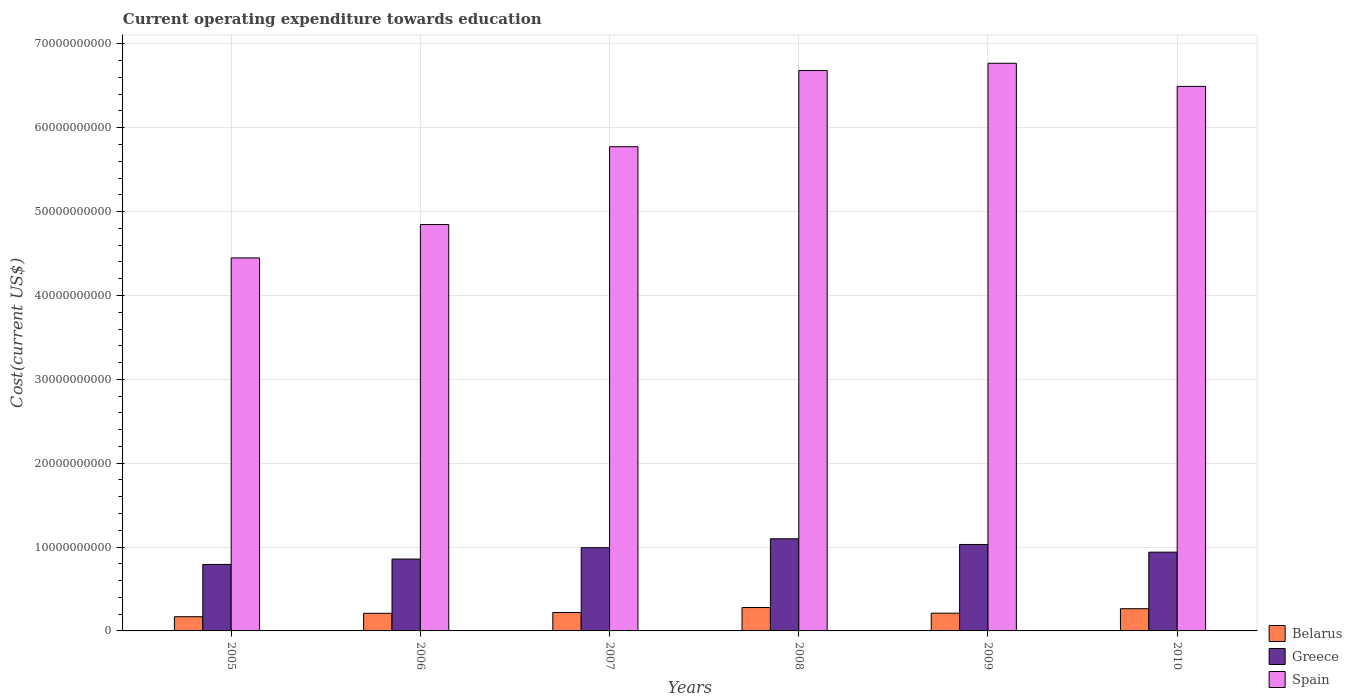How many different coloured bars are there?
Offer a terse response. 3. How many groups of bars are there?
Ensure brevity in your answer.  6. How many bars are there on the 5th tick from the right?
Make the answer very short. 3. What is the label of the 1st group of bars from the left?
Your answer should be compact. 2005. What is the expenditure towards education in Greece in 2005?
Your answer should be very brief. 7.93e+09. Across all years, what is the maximum expenditure towards education in Spain?
Offer a terse response. 6.77e+1. Across all years, what is the minimum expenditure towards education in Greece?
Your answer should be very brief. 7.93e+09. In which year was the expenditure towards education in Spain minimum?
Provide a short and direct response. 2005. What is the total expenditure towards education in Greece in the graph?
Your answer should be compact. 5.71e+1. What is the difference between the expenditure towards education in Belarus in 2005 and that in 2006?
Offer a terse response. -4.05e+08. What is the difference between the expenditure towards education in Greece in 2005 and the expenditure towards education in Belarus in 2006?
Offer a very short reply. 5.83e+09. What is the average expenditure towards education in Spain per year?
Your answer should be compact. 5.84e+1. In the year 2005, what is the difference between the expenditure towards education in Spain and expenditure towards education in Belarus?
Keep it short and to the point. 4.28e+1. What is the ratio of the expenditure towards education in Spain in 2005 to that in 2010?
Ensure brevity in your answer.  0.69. Is the difference between the expenditure towards education in Spain in 2008 and 2010 greater than the difference between the expenditure towards education in Belarus in 2008 and 2010?
Provide a short and direct response. Yes. What is the difference between the highest and the second highest expenditure towards education in Spain?
Ensure brevity in your answer.  8.66e+08. What is the difference between the highest and the lowest expenditure towards education in Greece?
Keep it short and to the point. 3.06e+09. In how many years, is the expenditure towards education in Spain greater than the average expenditure towards education in Spain taken over all years?
Provide a succinct answer. 3. Is the sum of the expenditure towards education in Greece in 2007 and 2010 greater than the maximum expenditure towards education in Belarus across all years?
Offer a terse response. Yes. What does the 2nd bar from the left in 2006 represents?
Provide a succinct answer. Greece. What does the 3rd bar from the right in 2005 represents?
Keep it short and to the point. Belarus. Is it the case that in every year, the sum of the expenditure towards education in Belarus and expenditure towards education in Spain is greater than the expenditure towards education in Greece?
Provide a short and direct response. Yes. Are all the bars in the graph horizontal?
Offer a terse response. No. Where does the legend appear in the graph?
Your answer should be compact. Bottom right. What is the title of the graph?
Ensure brevity in your answer.  Current operating expenditure towards education. What is the label or title of the X-axis?
Keep it short and to the point. Years. What is the label or title of the Y-axis?
Offer a terse response. Cost(current US$). What is the Cost(current US$) in Belarus in 2005?
Provide a succinct answer. 1.69e+09. What is the Cost(current US$) in Greece in 2005?
Keep it short and to the point. 7.93e+09. What is the Cost(current US$) in Spain in 2005?
Ensure brevity in your answer.  4.45e+1. What is the Cost(current US$) in Belarus in 2006?
Keep it short and to the point. 2.10e+09. What is the Cost(current US$) in Greece in 2006?
Your answer should be very brief. 8.57e+09. What is the Cost(current US$) in Spain in 2006?
Your response must be concise. 4.85e+1. What is the Cost(current US$) of Belarus in 2007?
Provide a short and direct response. 2.20e+09. What is the Cost(current US$) of Greece in 2007?
Your response must be concise. 9.92e+09. What is the Cost(current US$) in Spain in 2007?
Your response must be concise. 5.77e+1. What is the Cost(current US$) in Belarus in 2008?
Your answer should be compact. 2.79e+09. What is the Cost(current US$) in Greece in 2008?
Offer a terse response. 1.10e+1. What is the Cost(current US$) of Spain in 2008?
Give a very brief answer. 6.68e+1. What is the Cost(current US$) of Belarus in 2009?
Your response must be concise. 2.12e+09. What is the Cost(current US$) in Greece in 2009?
Keep it short and to the point. 1.03e+1. What is the Cost(current US$) of Spain in 2009?
Your answer should be very brief. 6.77e+1. What is the Cost(current US$) of Belarus in 2010?
Give a very brief answer. 2.65e+09. What is the Cost(current US$) of Greece in 2010?
Ensure brevity in your answer.  9.39e+09. What is the Cost(current US$) in Spain in 2010?
Make the answer very short. 6.49e+1. Across all years, what is the maximum Cost(current US$) of Belarus?
Offer a very short reply. 2.79e+09. Across all years, what is the maximum Cost(current US$) in Greece?
Keep it short and to the point. 1.10e+1. Across all years, what is the maximum Cost(current US$) in Spain?
Your response must be concise. 6.77e+1. Across all years, what is the minimum Cost(current US$) in Belarus?
Offer a terse response. 1.69e+09. Across all years, what is the minimum Cost(current US$) in Greece?
Ensure brevity in your answer.  7.93e+09. Across all years, what is the minimum Cost(current US$) in Spain?
Provide a short and direct response. 4.45e+1. What is the total Cost(current US$) of Belarus in the graph?
Provide a short and direct response. 1.35e+1. What is the total Cost(current US$) of Greece in the graph?
Give a very brief answer. 5.71e+1. What is the total Cost(current US$) in Spain in the graph?
Your response must be concise. 3.50e+11. What is the difference between the Cost(current US$) in Belarus in 2005 and that in 2006?
Offer a very short reply. -4.05e+08. What is the difference between the Cost(current US$) in Greece in 2005 and that in 2006?
Ensure brevity in your answer.  -6.41e+08. What is the difference between the Cost(current US$) of Spain in 2005 and that in 2006?
Offer a terse response. -3.98e+09. What is the difference between the Cost(current US$) of Belarus in 2005 and that in 2007?
Your answer should be very brief. -5.04e+08. What is the difference between the Cost(current US$) in Greece in 2005 and that in 2007?
Provide a succinct answer. -2.00e+09. What is the difference between the Cost(current US$) of Spain in 2005 and that in 2007?
Give a very brief answer. -1.33e+1. What is the difference between the Cost(current US$) in Belarus in 2005 and that in 2008?
Offer a very short reply. -1.09e+09. What is the difference between the Cost(current US$) in Greece in 2005 and that in 2008?
Offer a very short reply. -3.06e+09. What is the difference between the Cost(current US$) of Spain in 2005 and that in 2008?
Provide a short and direct response. -2.23e+1. What is the difference between the Cost(current US$) of Belarus in 2005 and that in 2009?
Your answer should be compact. -4.21e+08. What is the difference between the Cost(current US$) of Greece in 2005 and that in 2009?
Offer a very short reply. -2.38e+09. What is the difference between the Cost(current US$) in Spain in 2005 and that in 2009?
Offer a terse response. -2.32e+1. What is the difference between the Cost(current US$) in Belarus in 2005 and that in 2010?
Keep it short and to the point. -9.54e+08. What is the difference between the Cost(current US$) of Greece in 2005 and that in 2010?
Your response must be concise. -1.46e+09. What is the difference between the Cost(current US$) in Spain in 2005 and that in 2010?
Your answer should be very brief. -2.05e+1. What is the difference between the Cost(current US$) in Belarus in 2006 and that in 2007?
Your response must be concise. -9.81e+07. What is the difference between the Cost(current US$) of Greece in 2006 and that in 2007?
Offer a very short reply. -1.35e+09. What is the difference between the Cost(current US$) of Spain in 2006 and that in 2007?
Your answer should be compact. -9.28e+09. What is the difference between the Cost(current US$) of Belarus in 2006 and that in 2008?
Make the answer very short. -6.88e+08. What is the difference between the Cost(current US$) in Greece in 2006 and that in 2008?
Provide a succinct answer. -2.42e+09. What is the difference between the Cost(current US$) of Spain in 2006 and that in 2008?
Provide a succinct answer. -1.84e+1. What is the difference between the Cost(current US$) in Belarus in 2006 and that in 2009?
Provide a succinct answer. -1.59e+07. What is the difference between the Cost(current US$) of Greece in 2006 and that in 2009?
Give a very brief answer. -1.74e+09. What is the difference between the Cost(current US$) of Spain in 2006 and that in 2009?
Provide a succinct answer. -1.92e+1. What is the difference between the Cost(current US$) in Belarus in 2006 and that in 2010?
Provide a succinct answer. -5.49e+08. What is the difference between the Cost(current US$) of Greece in 2006 and that in 2010?
Your answer should be compact. -8.21e+08. What is the difference between the Cost(current US$) in Spain in 2006 and that in 2010?
Provide a succinct answer. -1.65e+1. What is the difference between the Cost(current US$) of Belarus in 2007 and that in 2008?
Provide a succinct answer. -5.90e+08. What is the difference between the Cost(current US$) of Greece in 2007 and that in 2008?
Keep it short and to the point. -1.06e+09. What is the difference between the Cost(current US$) in Spain in 2007 and that in 2008?
Provide a short and direct response. -9.08e+09. What is the difference between the Cost(current US$) in Belarus in 2007 and that in 2009?
Your answer should be very brief. 8.22e+07. What is the difference between the Cost(current US$) in Greece in 2007 and that in 2009?
Your answer should be compact. -3.84e+08. What is the difference between the Cost(current US$) in Spain in 2007 and that in 2009?
Your response must be concise. -9.95e+09. What is the difference between the Cost(current US$) of Belarus in 2007 and that in 2010?
Make the answer very short. -4.50e+08. What is the difference between the Cost(current US$) of Greece in 2007 and that in 2010?
Provide a short and direct response. 5.33e+08. What is the difference between the Cost(current US$) in Spain in 2007 and that in 2010?
Your response must be concise. -7.19e+09. What is the difference between the Cost(current US$) in Belarus in 2008 and that in 2009?
Offer a very short reply. 6.72e+08. What is the difference between the Cost(current US$) in Greece in 2008 and that in 2009?
Offer a terse response. 6.80e+08. What is the difference between the Cost(current US$) of Spain in 2008 and that in 2009?
Provide a short and direct response. -8.66e+08. What is the difference between the Cost(current US$) of Belarus in 2008 and that in 2010?
Your answer should be compact. 1.39e+08. What is the difference between the Cost(current US$) of Greece in 2008 and that in 2010?
Make the answer very short. 1.60e+09. What is the difference between the Cost(current US$) in Spain in 2008 and that in 2010?
Give a very brief answer. 1.89e+09. What is the difference between the Cost(current US$) of Belarus in 2009 and that in 2010?
Give a very brief answer. -5.33e+08. What is the difference between the Cost(current US$) of Greece in 2009 and that in 2010?
Give a very brief answer. 9.18e+08. What is the difference between the Cost(current US$) in Spain in 2009 and that in 2010?
Offer a terse response. 2.76e+09. What is the difference between the Cost(current US$) of Belarus in 2005 and the Cost(current US$) of Greece in 2006?
Offer a very short reply. -6.88e+09. What is the difference between the Cost(current US$) in Belarus in 2005 and the Cost(current US$) in Spain in 2006?
Give a very brief answer. -4.68e+1. What is the difference between the Cost(current US$) in Greece in 2005 and the Cost(current US$) in Spain in 2006?
Your response must be concise. -4.05e+1. What is the difference between the Cost(current US$) of Belarus in 2005 and the Cost(current US$) of Greece in 2007?
Provide a short and direct response. -8.23e+09. What is the difference between the Cost(current US$) of Belarus in 2005 and the Cost(current US$) of Spain in 2007?
Give a very brief answer. -5.60e+1. What is the difference between the Cost(current US$) in Greece in 2005 and the Cost(current US$) in Spain in 2007?
Provide a short and direct response. -4.98e+1. What is the difference between the Cost(current US$) of Belarus in 2005 and the Cost(current US$) of Greece in 2008?
Give a very brief answer. -9.29e+09. What is the difference between the Cost(current US$) of Belarus in 2005 and the Cost(current US$) of Spain in 2008?
Your response must be concise. -6.51e+1. What is the difference between the Cost(current US$) of Greece in 2005 and the Cost(current US$) of Spain in 2008?
Your response must be concise. -5.89e+1. What is the difference between the Cost(current US$) of Belarus in 2005 and the Cost(current US$) of Greece in 2009?
Provide a succinct answer. -8.61e+09. What is the difference between the Cost(current US$) of Belarus in 2005 and the Cost(current US$) of Spain in 2009?
Your answer should be very brief. -6.60e+1. What is the difference between the Cost(current US$) in Greece in 2005 and the Cost(current US$) in Spain in 2009?
Make the answer very short. -5.98e+1. What is the difference between the Cost(current US$) in Belarus in 2005 and the Cost(current US$) in Greece in 2010?
Your answer should be very brief. -7.70e+09. What is the difference between the Cost(current US$) of Belarus in 2005 and the Cost(current US$) of Spain in 2010?
Offer a terse response. -6.32e+1. What is the difference between the Cost(current US$) in Greece in 2005 and the Cost(current US$) in Spain in 2010?
Make the answer very short. -5.70e+1. What is the difference between the Cost(current US$) in Belarus in 2006 and the Cost(current US$) in Greece in 2007?
Offer a very short reply. -7.82e+09. What is the difference between the Cost(current US$) in Belarus in 2006 and the Cost(current US$) in Spain in 2007?
Your answer should be very brief. -5.56e+1. What is the difference between the Cost(current US$) of Greece in 2006 and the Cost(current US$) of Spain in 2007?
Offer a very short reply. -4.92e+1. What is the difference between the Cost(current US$) in Belarus in 2006 and the Cost(current US$) in Greece in 2008?
Make the answer very short. -8.89e+09. What is the difference between the Cost(current US$) in Belarus in 2006 and the Cost(current US$) in Spain in 2008?
Make the answer very short. -6.47e+1. What is the difference between the Cost(current US$) in Greece in 2006 and the Cost(current US$) in Spain in 2008?
Provide a succinct answer. -5.83e+1. What is the difference between the Cost(current US$) of Belarus in 2006 and the Cost(current US$) of Greece in 2009?
Your response must be concise. -8.21e+09. What is the difference between the Cost(current US$) in Belarus in 2006 and the Cost(current US$) in Spain in 2009?
Your answer should be compact. -6.56e+1. What is the difference between the Cost(current US$) in Greece in 2006 and the Cost(current US$) in Spain in 2009?
Make the answer very short. -5.91e+1. What is the difference between the Cost(current US$) of Belarus in 2006 and the Cost(current US$) of Greece in 2010?
Ensure brevity in your answer.  -7.29e+09. What is the difference between the Cost(current US$) in Belarus in 2006 and the Cost(current US$) in Spain in 2010?
Keep it short and to the point. -6.28e+1. What is the difference between the Cost(current US$) in Greece in 2006 and the Cost(current US$) in Spain in 2010?
Give a very brief answer. -5.64e+1. What is the difference between the Cost(current US$) in Belarus in 2007 and the Cost(current US$) in Greece in 2008?
Your response must be concise. -8.79e+09. What is the difference between the Cost(current US$) of Belarus in 2007 and the Cost(current US$) of Spain in 2008?
Provide a short and direct response. -6.46e+1. What is the difference between the Cost(current US$) in Greece in 2007 and the Cost(current US$) in Spain in 2008?
Keep it short and to the point. -5.69e+1. What is the difference between the Cost(current US$) of Belarus in 2007 and the Cost(current US$) of Greece in 2009?
Make the answer very short. -8.11e+09. What is the difference between the Cost(current US$) in Belarus in 2007 and the Cost(current US$) in Spain in 2009?
Give a very brief answer. -6.55e+1. What is the difference between the Cost(current US$) of Greece in 2007 and the Cost(current US$) of Spain in 2009?
Provide a succinct answer. -5.78e+1. What is the difference between the Cost(current US$) in Belarus in 2007 and the Cost(current US$) in Greece in 2010?
Offer a very short reply. -7.19e+09. What is the difference between the Cost(current US$) of Belarus in 2007 and the Cost(current US$) of Spain in 2010?
Provide a short and direct response. -6.27e+1. What is the difference between the Cost(current US$) in Greece in 2007 and the Cost(current US$) in Spain in 2010?
Your response must be concise. -5.50e+1. What is the difference between the Cost(current US$) of Belarus in 2008 and the Cost(current US$) of Greece in 2009?
Provide a short and direct response. -7.52e+09. What is the difference between the Cost(current US$) in Belarus in 2008 and the Cost(current US$) in Spain in 2009?
Give a very brief answer. -6.49e+1. What is the difference between the Cost(current US$) of Greece in 2008 and the Cost(current US$) of Spain in 2009?
Make the answer very short. -5.67e+1. What is the difference between the Cost(current US$) of Belarus in 2008 and the Cost(current US$) of Greece in 2010?
Your answer should be compact. -6.60e+09. What is the difference between the Cost(current US$) in Belarus in 2008 and the Cost(current US$) in Spain in 2010?
Keep it short and to the point. -6.21e+1. What is the difference between the Cost(current US$) in Greece in 2008 and the Cost(current US$) in Spain in 2010?
Ensure brevity in your answer.  -5.39e+1. What is the difference between the Cost(current US$) in Belarus in 2009 and the Cost(current US$) in Greece in 2010?
Offer a terse response. -7.27e+09. What is the difference between the Cost(current US$) in Belarus in 2009 and the Cost(current US$) in Spain in 2010?
Give a very brief answer. -6.28e+1. What is the difference between the Cost(current US$) in Greece in 2009 and the Cost(current US$) in Spain in 2010?
Ensure brevity in your answer.  -5.46e+1. What is the average Cost(current US$) of Belarus per year?
Give a very brief answer. 2.26e+09. What is the average Cost(current US$) in Greece per year?
Your answer should be very brief. 9.52e+09. What is the average Cost(current US$) of Spain per year?
Provide a short and direct response. 5.84e+1. In the year 2005, what is the difference between the Cost(current US$) in Belarus and Cost(current US$) in Greece?
Make the answer very short. -6.23e+09. In the year 2005, what is the difference between the Cost(current US$) of Belarus and Cost(current US$) of Spain?
Offer a very short reply. -4.28e+1. In the year 2005, what is the difference between the Cost(current US$) of Greece and Cost(current US$) of Spain?
Provide a short and direct response. -3.66e+1. In the year 2006, what is the difference between the Cost(current US$) of Belarus and Cost(current US$) of Greece?
Your answer should be compact. -6.47e+09. In the year 2006, what is the difference between the Cost(current US$) in Belarus and Cost(current US$) in Spain?
Your answer should be very brief. -4.64e+1. In the year 2006, what is the difference between the Cost(current US$) of Greece and Cost(current US$) of Spain?
Provide a short and direct response. -3.99e+1. In the year 2007, what is the difference between the Cost(current US$) in Belarus and Cost(current US$) in Greece?
Ensure brevity in your answer.  -7.73e+09. In the year 2007, what is the difference between the Cost(current US$) of Belarus and Cost(current US$) of Spain?
Give a very brief answer. -5.55e+1. In the year 2007, what is the difference between the Cost(current US$) of Greece and Cost(current US$) of Spain?
Make the answer very short. -4.78e+1. In the year 2008, what is the difference between the Cost(current US$) in Belarus and Cost(current US$) in Greece?
Your response must be concise. -8.20e+09. In the year 2008, what is the difference between the Cost(current US$) in Belarus and Cost(current US$) in Spain?
Your answer should be very brief. -6.40e+1. In the year 2008, what is the difference between the Cost(current US$) of Greece and Cost(current US$) of Spain?
Your answer should be very brief. -5.58e+1. In the year 2009, what is the difference between the Cost(current US$) in Belarus and Cost(current US$) in Greece?
Keep it short and to the point. -8.19e+09. In the year 2009, what is the difference between the Cost(current US$) of Belarus and Cost(current US$) of Spain?
Make the answer very short. -6.56e+1. In the year 2009, what is the difference between the Cost(current US$) of Greece and Cost(current US$) of Spain?
Ensure brevity in your answer.  -5.74e+1. In the year 2010, what is the difference between the Cost(current US$) in Belarus and Cost(current US$) in Greece?
Your response must be concise. -6.74e+09. In the year 2010, what is the difference between the Cost(current US$) in Belarus and Cost(current US$) in Spain?
Your answer should be very brief. -6.23e+1. In the year 2010, what is the difference between the Cost(current US$) of Greece and Cost(current US$) of Spain?
Ensure brevity in your answer.  -5.55e+1. What is the ratio of the Cost(current US$) of Belarus in 2005 to that in 2006?
Make the answer very short. 0.81. What is the ratio of the Cost(current US$) of Greece in 2005 to that in 2006?
Keep it short and to the point. 0.93. What is the ratio of the Cost(current US$) of Spain in 2005 to that in 2006?
Your response must be concise. 0.92. What is the ratio of the Cost(current US$) of Belarus in 2005 to that in 2007?
Give a very brief answer. 0.77. What is the ratio of the Cost(current US$) in Greece in 2005 to that in 2007?
Your answer should be very brief. 0.8. What is the ratio of the Cost(current US$) in Spain in 2005 to that in 2007?
Your answer should be compact. 0.77. What is the ratio of the Cost(current US$) in Belarus in 2005 to that in 2008?
Offer a terse response. 0.61. What is the ratio of the Cost(current US$) in Greece in 2005 to that in 2008?
Give a very brief answer. 0.72. What is the ratio of the Cost(current US$) of Spain in 2005 to that in 2008?
Offer a terse response. 0.67. What is the ratio of the Cost(current US$) of Belarus in 2005 to that in 2009?
Your response must be concise. 0.8. What is the ratio of the Cost(current US$) of Greece in 2005 to that in 2009?
Offer a terse response. 0.77. What is the ratio of the Cost(current US$) of Spain in 2005 to that in 2009?
Your response must be concise. 0.66. What is the ratio of the Cost(current US$) in Belarus in 2005 to that in 2010?
Offer a very short reply. 0.64. What is the ratio of the Cost(current US$) of Greece in 2005 to that in 2010?
Ensure brevity in your answer.  0.84. What is the ratio of the Cost(current US$) in Spain in 2005 to that in 2010?
Give a very brief answer. 0.69. What is the ratio of the Cost(current US$) in Belarus in 2006 to that in 2007?
Make the answer very short. 0.96. What is the ratio of the Cost(current US$) in Greece in 2006 to that in 2007?
Provide a short and direct response. 0.86. What is the ratio of the Cost(current US$) in Spain in 2006 to that in 2007?
Ensure brevity in your answer.  0.84. What is the ratio of the Cost(current US$) of Belarus in 2006 to that in 2008?
Offer a terse response. 0.75. What is the ratio of the Cost(current US$) of Greece in 2006 to that in 2008?
Keep it short and to the point. 0.78. What is the ratio of the Cost(current US$) of Spain in 2006 to that in 2008?
Your answer should be very brief. 0.73. What is the ratio of the Cost(current US$) of Greece in 2006 to that in 2009?
Keep it short and to the point. 0.83. What is the ratio of the Cost(current US$) of Spain in 2006 to that in 2009?
Your answer should be very brief. 0.72. What is the ratio of the Cost(current US$) of Belarus in 2006 to that in 2010?
Keep it short and to the point. 0.79. What is the ratio of the Cost(current US$) in Greece in 2006 to that in 2010?
Give a very brief answer. 0.91. What is the ratio of the Cost(current US$) of Spain in 2006 to that in 2010?
Your answer should be compact. 0.75. What is the ratio of the Cost(current US$) in Belarus in 2007 to that in 2008?
Your response must be concise. 0.79. What is the ratio of the Cost(current US$) in Greece in 2007 to that in 2008?
Provide a short and direct response. 0.9. What is the ratio of the Cost(current US$) of Spain in 2007 to that in 2008?
Your answer should be very brief. 0.86. What is the ratio of the Cost(current US$) of Belarus in 2007 to that in 2009?
Your response must be concise. 1.04. What is the ratio of the Cost(current US$) of Greece in 2007 to that in 2009?
Provide a succinct answer. 0.96. What is the ratio of the Cost(current US$) in Spain in 2007 to that in 2009?
Make the answer very short. 0.85. What is the ratio of the Cost(current US$) in Belarus in 2007 to that in 2010?
Your answer should be very brief. 0.83. What is the ratio of the Cost(current US$) in Greece in 2007 to that in 2010?
Offer a terse response. 1.06. What is the ratio of the Cost(current US$) of Spain in 2007 to that in 2010?
Ensure brevity in your answer.  0.89. What is the ratio of the Cost(current US$) in Belarus in 2008 to that in 2009?
Your answer should be very brief. 1.32. What is the ratio of the Cost(current US$) in Greece in 2008 to that in 2009?
Provide a short and direct response. 1.07. What is the ratio of the Cost(current US$) in Spain in 2008 to that in 2009?
Provide a short and direct response. 0.99. What is the ratio of the Cost(current US$) in Belarus in 2008 to that in 2010?
Provide a short and direct response. 1.05. What is the ratio of the Cost(current US$) of Greece in 2008 to that in 2010?
Provide a succinct answer. 1.17. What is the ratio of the Cost(current US$) in Spain in 2008 to that in 2010?
Your answer should be very brief. 1.03. What is the ratio of the Cost(current US$) in Belarus in 2009 to that in 2010?
Your response must be concise. 0.8. What is the ratio of the Cost(current US$) of Greece in 2009 to that in 2010?
Give a very brief answer. 1.1. What is the ratio of the Cost(current US$) in Spain in 2009 to that in 2010?
Your answer should be very brief. 1.04. What is the difference between the highest and the second highest Cost(current US$) of Belarus?
Make the answer very short. 1.39e+08. What is the difference between the highest and the second highest Cost(current US$) of Greece?
Your answer should be compact. 6.80e+08. What is the difference between the highest and the second highest Cost(current US$) of Spain?
Keep it short and to the point. 8.66e+08. What is the difference between the highest and the lowest Cost(current US$) in Belarus?
Provide a short and direct response. 1.09e+09. What is the difference between the highest and the lowest Cost(current US$) in Greece?
Your answer should be compact. 3.06e+09. What is the difference between the highest and the lowest Cost(current US$) of Spain?
Ensure brevity in your answer.  2.32e+1. 